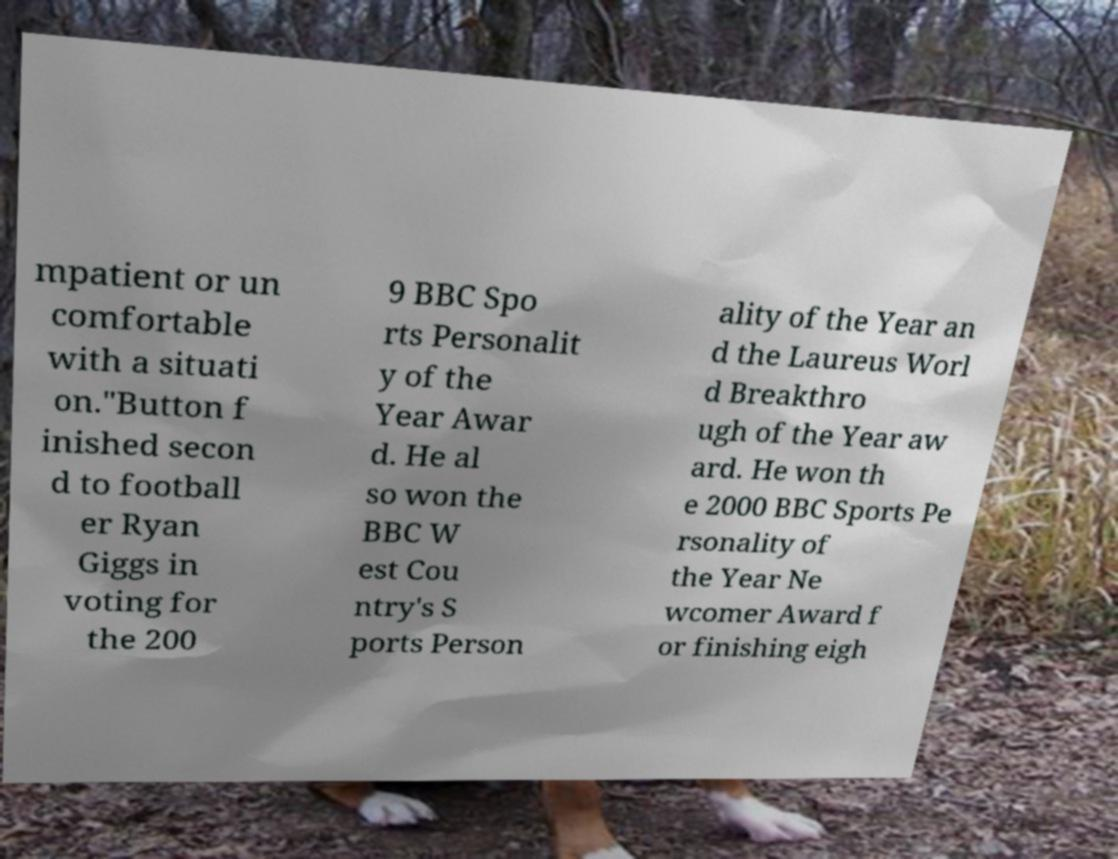I need the written content from this picture converted into text. Can you do that? mpatient or un comfortable with a situati on."Button f inished secon d to football er Ryan Giggs in voting for the 200 9 BBC Spo rts Personalit y of the Year Awar d. He al so won the BBC W est Cou ntry's S ports Person ality of the Year an d the Laureus Worl d Breakthro ugh of the Year aw ard. He won th e 2000 BBC Sports Pe rsonality of the Year Ne wcomer Award f or finishing eigh 